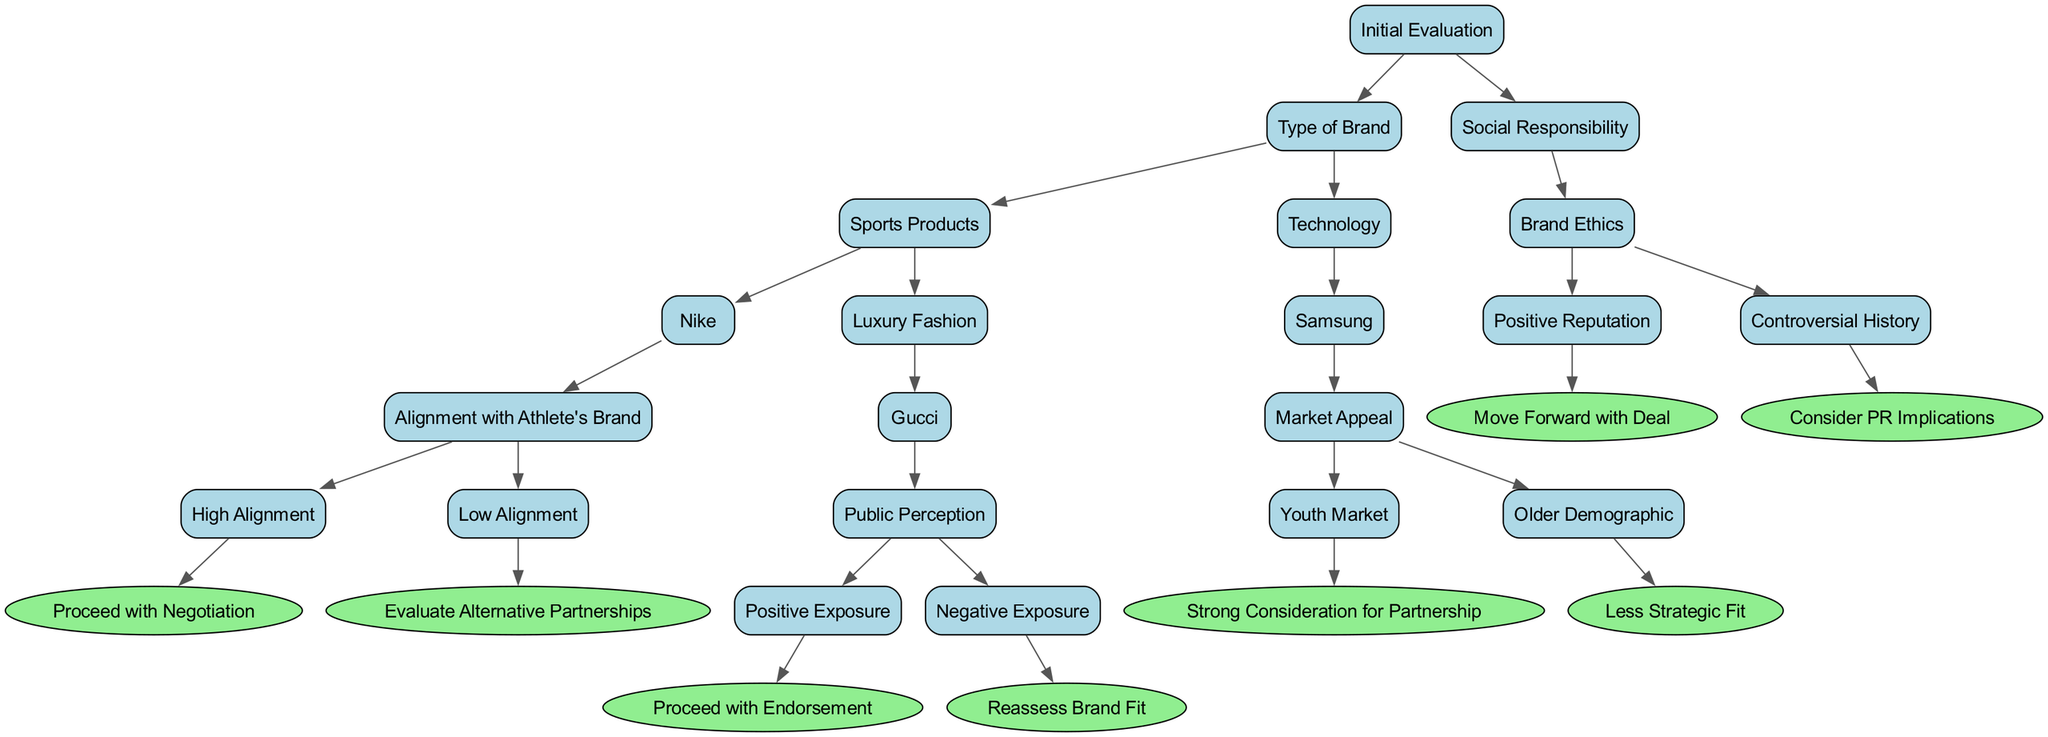What is the first node in the decision tree? The first node, or root, of the decision tree is "Initial Evaluation". This is the starting point of the decision-making process represented in the diagram.
Answer: Initial Evaluation How many branches are off the "Type of Brand" node? The "Type of Brand" node has three branches: "Sports Products", "Technology", and they lead to further branching or leaves. Counting these gives a total of 2 branches.
Answer: 2 What is the result if there is low alignment with Nike? If there is low alignment with Nike under the "Sports Products" category, the outcome is "Evaluate Alternative Partnerships". This step emphasizes the reconsideration of options when brand alignment is not favorable.
Answer: Evaluate Alternative Partnerships What do we do if we encounter a "Controversial History" under Brand Ethics? If the evaluation leads to "Controversial History" under "Brand Ethics", the recommendation is to "Consider PR Implications". This highlights the need to think critically about potential public relations consequences before proceeding.
Answer: Consider PR Implications What does strong market appeal indicate when reviewing Samsung? If Samsung has a "Youth Market" as the market appeal, the next step indicates a "Strong Consideration for Partnership". This shows that appealing to a youth demographic is seen as valuable for the brand ambassador role.
Answer: Strong Consideration for Partnership What happens under "Luxury Fashion" if public perception is negative? If public perception is "Negative Exposure" under "Gucci", the outcome is to "Reassess Brand Fit", meaning the brand's suitability needs to be evaluated again due to the negative public viewpoint.
Answer: Reassess Brand Fit Is there an outcome when the brand ethics are positively received? Yes, if the "Brand Ethics" node leads to "Positive Reputation", the recommendation is to "Move Forward with Deal". This indicates a clear go-ahead when brand ethics align positively.
Answer: Move Forward with Deal What is the next step if there is positive exposure from Gucci? If there is "Positive Exposure" from Gucci, it leads directly to "Proceed with Endorsement". This indicates a favorable outcome and supports the decision to proceed with the partnership.
Answer: Proceed with Endorsement 